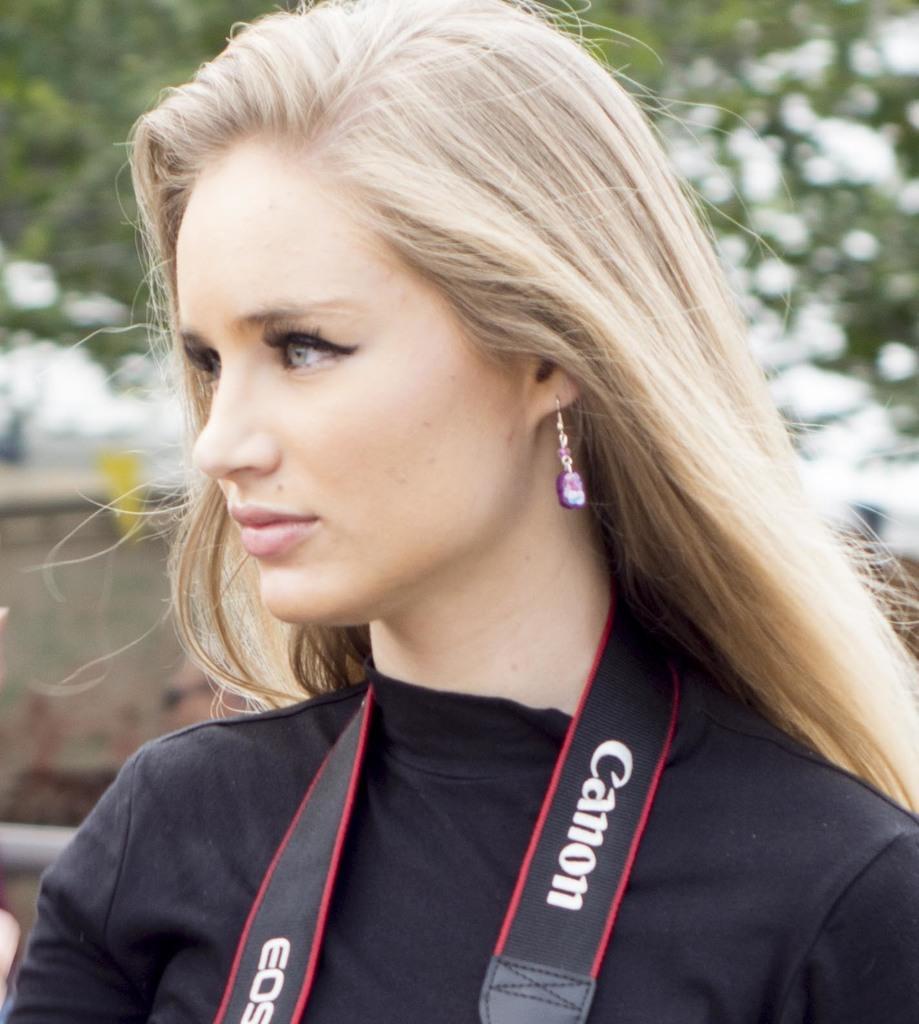Please provide a concise description of this image. In the image we can see close up image of a woman wearing clothes earring. Here we can see camera belt around her neck and the background is blurred. 